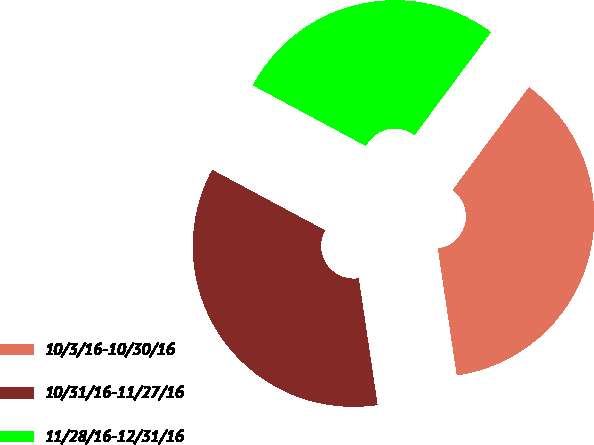Convert chart. <chart><loc_0><loc_0><loc_500><loc_500><pie_chart><fcel>10/3/16-10/30/16<fcel>10/31/16-11/27/16<fcel>11/28/16-12/31/16<nl><fcel>37.48%<fcel>35.19%<fcel>27.33%<nl></chart> 